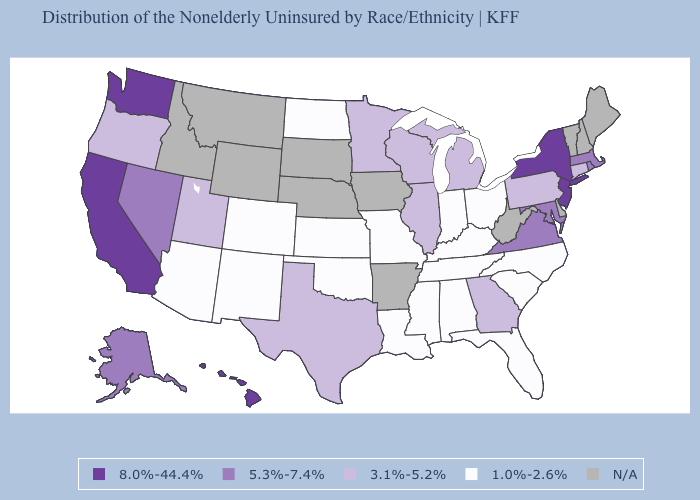What is the value of Mississippi?
Keep it brief. 1.0%-2.6%. What is the lowest value in the USA?
Give a very brief answer. 1.0%-2.6%. Does the map have missing data?
Be succinct. Yes. What is the value of Oregon?
Keep it brief. 3.1%-5.2%. What is the lowest value in states that border Maryland?
Answer briefly. 3.1%-5.2%. Does New Jersey have the highest value in the Northeast?
Answer briefly. Yes. Name the states that have a value in the range 3.1%-5.2%?
Short answer required. Connecticut, Georgia, Illinois, Michigan, Minnesota, Oregon, Pennsylvania, Texas, Utah, Wisconsin. Which states have the lowest value in the Northeast?
Give a very brief answer. Connecticut, Pennsylvania. What is the lowest value in the South?
Quick response, please. 1.0%-2.6%. Is the legend a continuous bar?
Quick response, please. No. Which states hav the highest value in the South?
Write a very short answer. Maryland, Virginia. What is the value of Georgia?
Be succinct. 3.1%-5.2%. What is the value of Illinois?
Answer briefly. 3.1%-5.2%. What is the value of Mississippi?
Keep it brief. 1.0%-2.6%. What is the value of Arkansas?
Short answer required. N/A. 